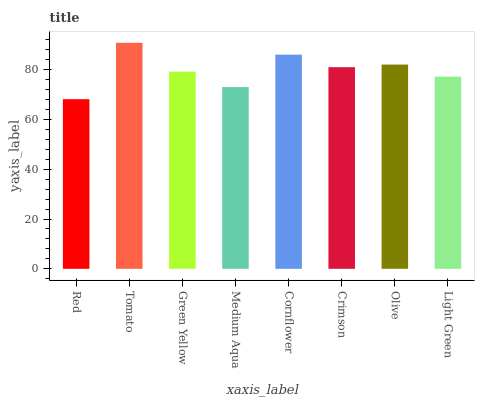Is Green Yellow the minimum?
Answer yes or no. No. Is Green Yellow the maximum?
Answer yes or no. No. Is Tomato greater than Green Yellow?
Answer yes or no. Yes. Is Green Yellow less than Tomato?
Answer yes or no. Yes. Is Green Yellow greater than Tomato?
Answer yes or no. No. Is Tomato less than Green Yellow?
Answer yes or no. No. Is Crimson the high median?
Answer yes or no. Yes. Is Green Yellow the low median?
Answer yes or no. Yes. Is Red the high median?
Answer yes or no. No. Is Red the low median?
Answer yes or no. No. 